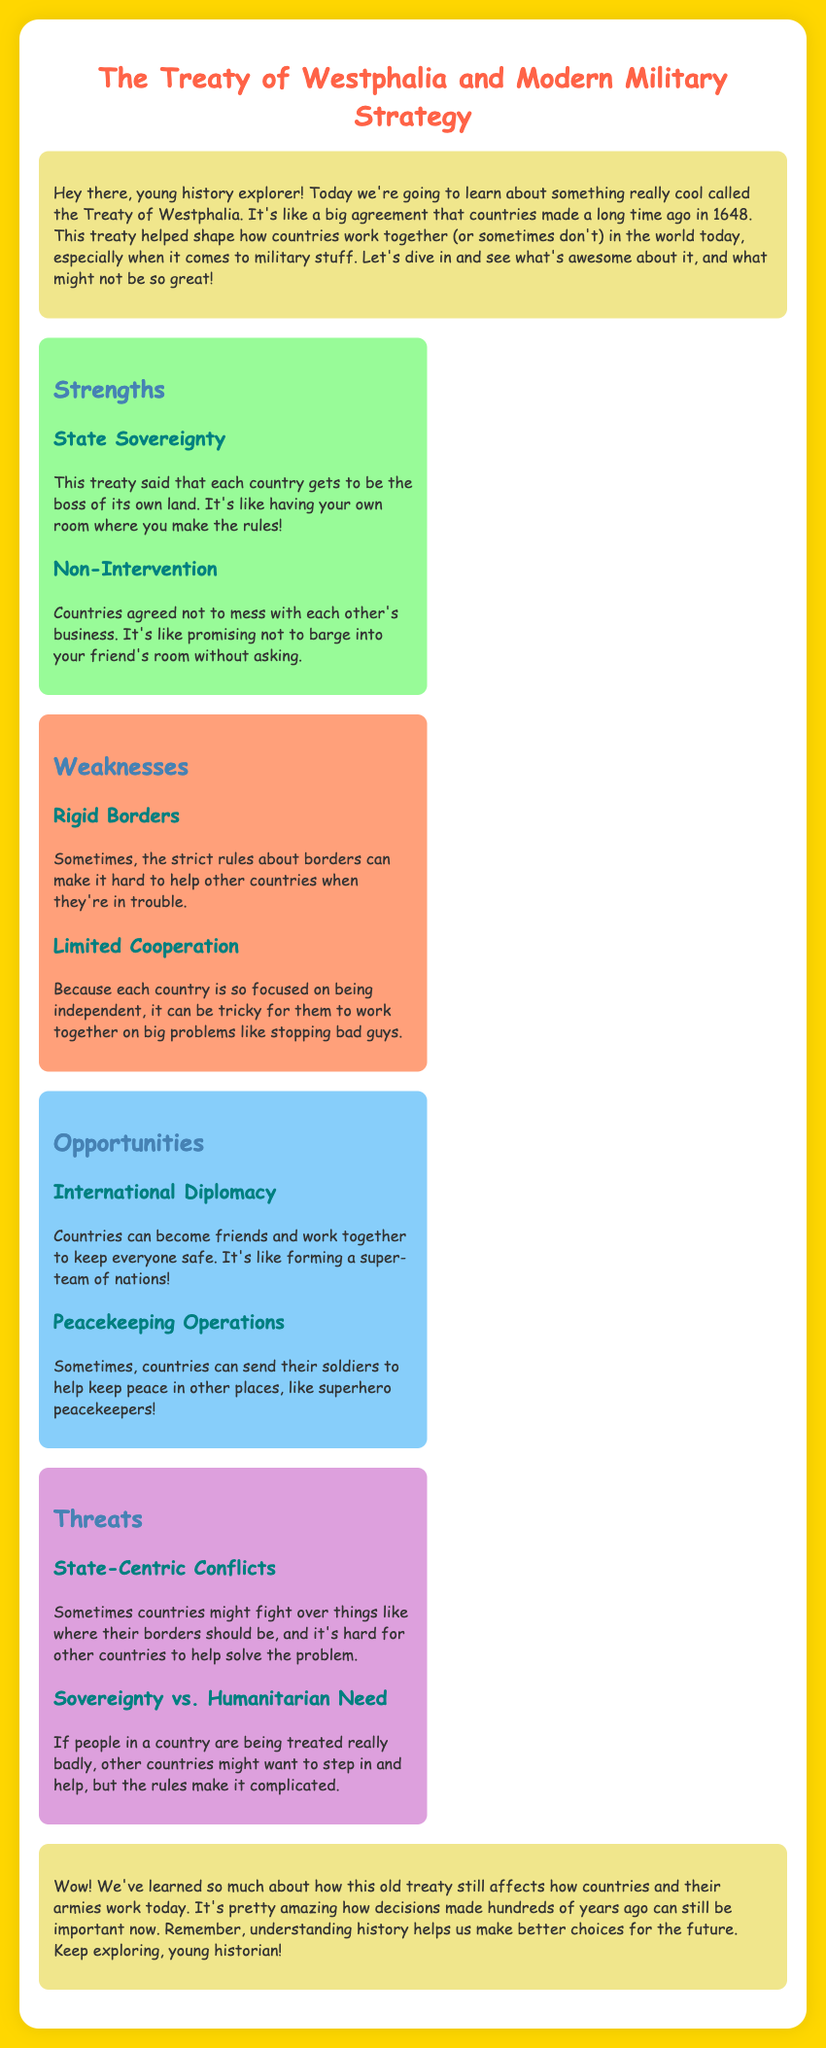What is the title of the document? The title is mentioned at the very top of the document.
Answer: The Treaty of Westphalia and Modern Military Strategy In what year was the Treaty of Westphalia concluded? The document specifies this important date in the introduction.
Answer: 1648 What are the two main strengths of the Treaty of Westphalia? The document lists the strengths under the strengths section.
Answer: State Sovereignty, Non-Intervention What is one weakness of the Treaty of Westphalia? The weaknesses are detailed in the weaknesses section of the document.
Answer: Rigid Borders What kind of opportunities does the Treaty of Westphalia provide? Opportunities are outlined in the opportunities section, reflecting potential positive outcomes.
Answer: International Diplomacy, Peacekeeping Operations What are two threats mentioned in the document? The threats are outlined in the threats section, listing potential dangers.
Answer: State-Centric Conflicts, Sovereignty vs. Humanitarian Need What is the purpose of the concluding paragraph? The conclusion summarizes the document's main points and encourages further exploration of history.
Answer: To reflect on the significance of the treaty 